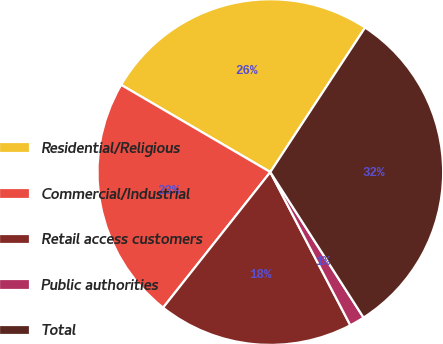Convert chart to OTSL. <chart><loc_0><loc_0><loc_500><loc_500><pie_chart><fcel>Residential/Religious<fcel>Commercial/Industrial<fcel>Retail access customers<fcel>Public authorities<fcel>Total<nl><fcel>25.82%<fcel>22.77%<fcel>18.31%<fcel>1.41%<fcel>31.69%<nl></chart> 